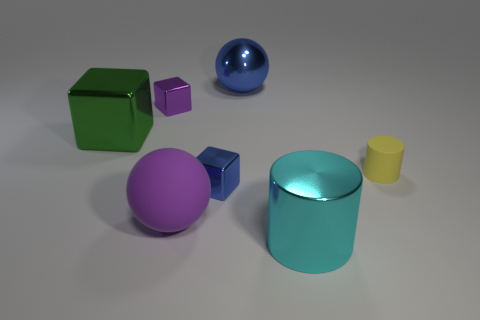There is a metal object that is the same color as the rubber sphere; what is its size?
Your answer should be very brief. Small. There is a tiny shiny block that is in front of the rubber cylinder; is it the same color as the big shiny sphere?
Your response must be concise. Yes. There is another object that is the same color as the large matte object; what shape is it?
Give a very brief answer. Cube. Is there a red cube made of the same material as the big blue object?
Keep it short and to the point. No. The small purple shiny thing is what shape?
Your answer should be very brief. Cube. What number of tiny yellow metallic cubes are there?
Keep it short and to the point. 0. There is a matte thing that is on the right side of the shiny object to the right of the shiny ball; what is its color?
Your answer should be compact. Yellow. There is a rubber object that is the same size as the blue block; what is its color?
Your answer should be very brief. Yellow. Is there a object of the same color as the big rubber ball?
Your answer should be very brief. Yes. Are any small blue blocks visible?
Give a very brief answer. Yes. 